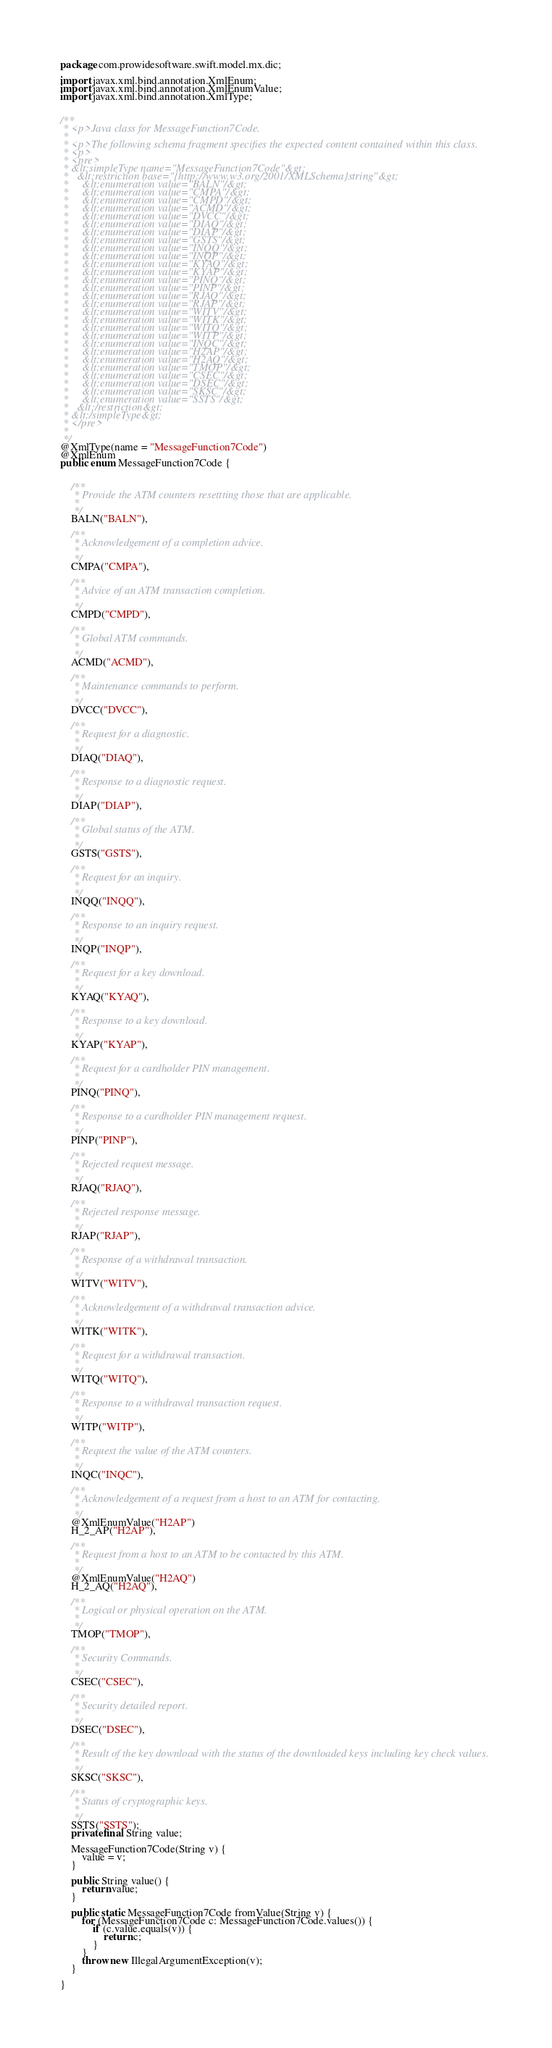Convert code to text. <code><loc_0><loc_0><loc_500><loc_500><_Java_>
package com.prowidesoftware.swift.model.mx.dic;

import javax.xml.bind.annotation.XmlEnum;
import javax.xml.bind.annotation.XmlEnumValue;
import javax.xml.bind.annotation.XmlType;


/**
 * <p>Java class for MessageFunction7Code.
 * 
 * <p>The following schema fragment specifies the expected content contained within this class.
 * <p>
 * <pre>
 * &lt;simpleType name="MessageFunction7Code"&gt;
 *   &lt;restriction base="{http://www.w3.org/2001/XMLSchema}string"&gt;
 *     &lt;enumeration value="BALN"/&gt;
 *     &lt;enumeration value="CMPA"/&gt;
 *     &lt;enumeration value="CMPD"/&gt;
 *     &lt;enumeration value="ACMD"/&gt;
 *     &lt;enumeration value="DVCC"/&gt;
 *     &lt;enumeration value="DIAQ"/&gt;
 *     &lt;enumeration value="DIAP"/&gt;
 *     &lt;enumeration value="GSTS"/&gt;
 *     &lt;enumeration value="INQQ"/&gt;
 *     &lt;enumeration value="INQP"/&gt;
 *     &lt;enumeration value="KYAQ"/&gt;
 *     &lt;enumeration value="KYAP"/&gt;
 *     &lt;enumeration value="PINQ"/&gt;
 *     &lt;enumeration value="PINP"/&gt;
 *     &lt;enumeration value="RJAQ"/&gt;
 *     &lt;enumeration value="RJAP"/&gt;
 *     &lt;enumeration value="WITV"/&gt;
 *     &lt;enumeration value="WITK"/&gt;
 *     &lt;enumeration value="WITQ"/&gt;
 *     &lt;enumeration value="WITP"/&gt;
 *     &lt;enumeration value="INQC"/&gt;
 *     &lt;enumeration value="H2AP"/&gt;
 *     &lt;enumeration value="H2AQ"/&gt;
 *     &lt;enumeration value="TMOP"/&gt;
 *     &lt;enumeration value="CSEC"/&gt;
 *     &lt;enumeration value="DSEC"/&gt;
 *     &lt;enumeration value="SKSC"/&gt;
 *     &lt;enumeration value="SSTS"/&gt;
 *   &lt;/restriction&gt;
 * &lt;/simpleType&gt;
 * </pre>
 * 
 */
@XmlType(name = "MessageFunction7Code")
@XmlEnum
public enum MessageFunction7Code {


    /**
     * Provide the ATM counters resettting those that are applicable.
     * 
     */
    BALN("BALN"),

    /**
     * Acknowledgement of a completion advice.
     * 
     */
    CMPA("CMPA"),

    /**
     * Advice of an ATM transaction completion.
     * 
     */
    CMPD("CMPD"),

    /**
     * Global ATM commands.
     * 
     */
    ACMD("ACMD"),

    /**
     * Maintenance commands to perform.
     * 
     */
    DVCC("DVCC"),

    /**
     * Request for a diagnostic.
     * 
     */
    DIAQ("DIAQ"),

    /**
     * Response to a diagnostic request.
     * 
     */
    DIAP("DIAP"),

    /**
     * Global status of the ATM.
     * 
     */
    GSTS("GSTS"),

    /**
     * Request for an inquiry.
     * 
     */
    INQQ("INQQ"),

    /**
     * Response to an inquiry request.
     * 
     */
    INQP("INQP"),

    /**
     * Request for a key download.
     * 
     */
    KYAQ("KYAQ"),

    /**
     * Response to a key download.
     * 
     */
    KYAP("KYAP"),

    /**
     * Request for a cardholder PIN management.
     * 
     */
    PINQ("PINQ"),

    /**
     * Response to a cardholder PIN management request.
     * 
     */
    PINP("PINP"),

    /**
     * Rejected request message.
     * 
     */
    RJAQ("RJAQ"),

    /**
     * Rejected response message.
     * 
     */
    RJAP("RJAP"),

    /**
     * Response of a withdrawal transaction.
     * 
     */
    WITV("WITV"),

    /**
     * Acknowledgement of a withdrawal transaction advice.
     * 
     */
    WITK("WITK"),

    /**
     * Request for a withdrawal transaction.
     * 
     */
    WITQ("WITQ"),

    /**
     * Response to a withdrawal transaction request.
     * 
     */
    WITP("WITP"),

    /**
     * Request the value of the ATM counters.
     * 
     */
    INQC("INQC"),

    /**
     * Acknowledgement of a request from a host to an ATM for contacting.
     * 
     */
    @XmlEnumValue("H2AP")
    H_2_AP("H2AP"),

    /**
     * Request from a host to an ATM to be contacted by this ATM.
     * 
     */
    @XmlEnumValue("H2AQ")
    H_2_AQ("H2AQ"),

    /**
     * Logical or physical operation on the ATM.
     * 
     */
    TMOP("TMOP"),

    /**
     * Security Commands.
     * 
     */
    CSEC("CSEC"),

    /**
     * Security detailed report.
     * 
     */
    DSEC("DSEC"),

    /**
     * Result of the key download with the status of the downloaded keys including key check values.
     * 
     */
    SKSC("SKSC"),

    /**
     * Status of cryptographic keys.
     * 
     */
    SSTS("SSTS");
    private final String value;

    MessageFunction7Code(String v) {
        value = v;
    }

    public String value() {
        return value;
    }

    public static MessageFunction7Code fromValue(String v) {
        for (MessageFunction7Code c: MessageFunction7Code.values()) {
            if (c.value.equals(v)) {
                return c;
            }
        }
        throw new IllegalArgumentException(v);
    }

}
</code> 